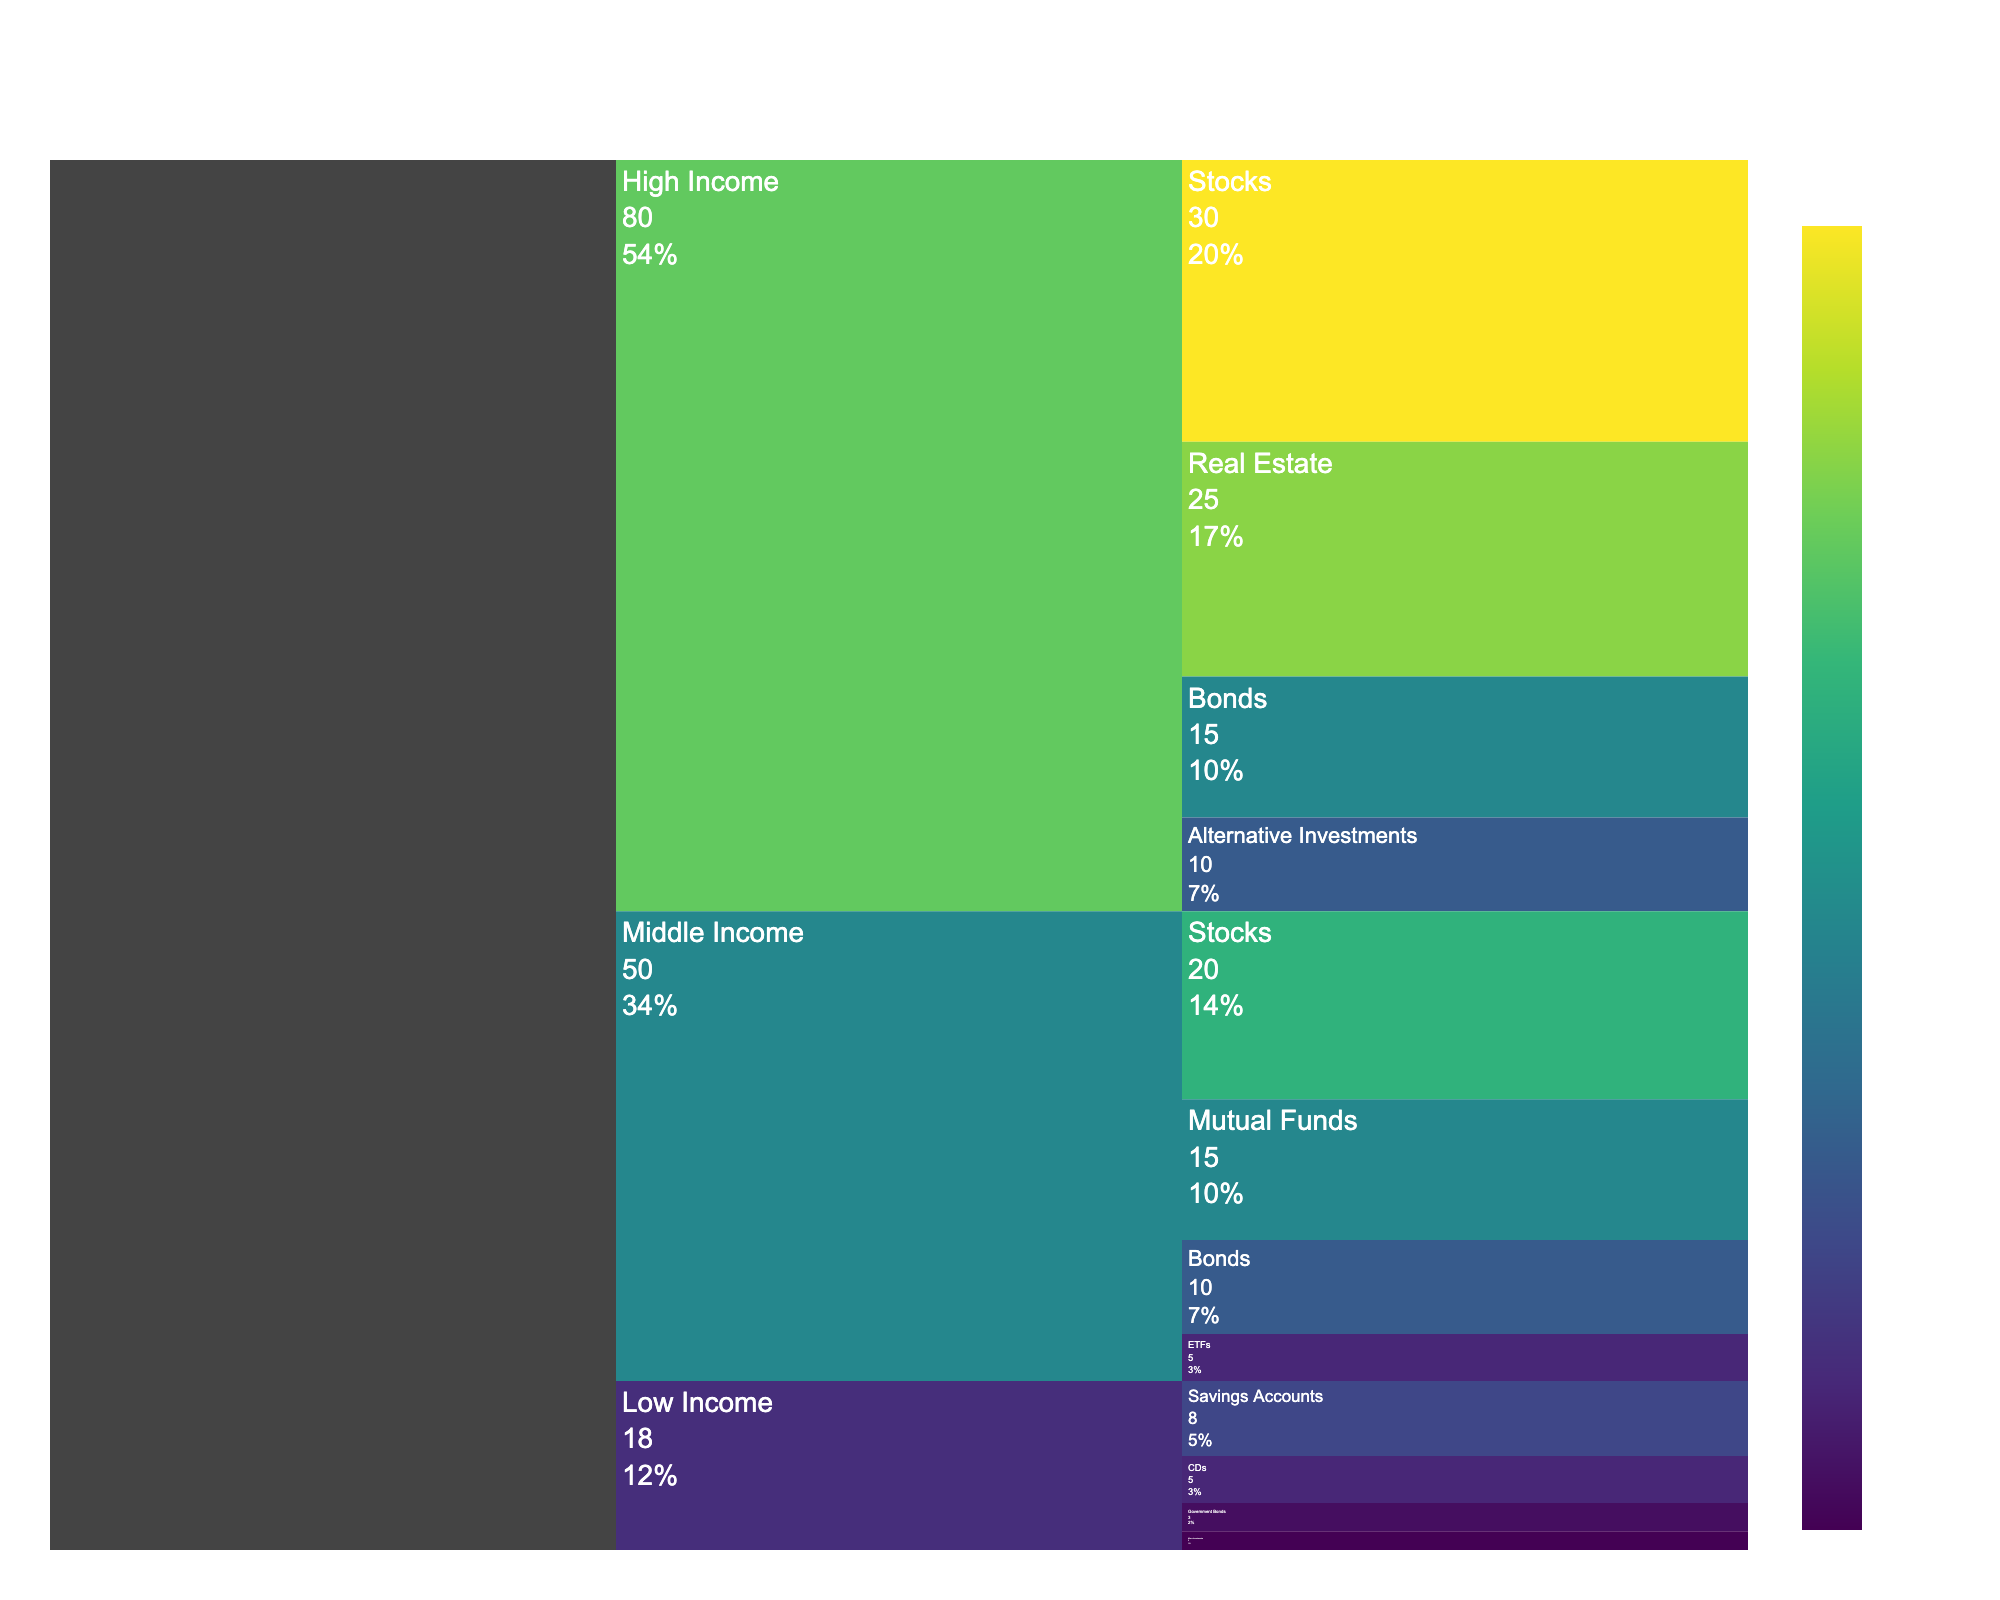What is the title of the Icicle chart? The title of the Icicle chart is positioned at the top, centered, and written in a large font.
Answer: Client Wealth Distribution by Income Bracket and Investment Type What color represents higher values on the chart? The chart uses a color scale to indicate values, where higher values are represented by colors towards the end of the Viridis color scale, typically in shades of yellow and green.
Answer: Shades of yellow and green Which investment type has the highest value for the High Income bracket? By examining the section of the Icicle chart related to the High Income bracket, you can see that the largest segment within this section is colored darker and has the highest value indicated in the hover information.
Answer: Stocks What is the total value of investments in the Middle Income bracket? To find this value, sum the indicated values of the investments (20 for Stocks, 10 for Bonds, 15 for Mutual Funds, and 5 for ETFs). So, 20 + 10 + 15 + 5 = 50.
Answer: 50 Compare the value of Stocks investments between High Income and Middle Income brackets. Which is larger? Compare the values directly from the chart; High Income has 30 and Middle Income has 20.
Answer: High Income What percentage of the total investment does the Real Estate segment represent in the High Income bracket? First, find the value for Real Estate in High Income (25). Then, find the total for High Income investments: 30 (Stocks) + 15 (Bonds) + 25 (Real Estate) + 10 (Alternative Investments) = 80. Finally, calculate the percentage (25/80) * 100 = 31.25%.
Answer: 31.25% How does the value of Government Bonds in the Low Income bracket compare to Bonds in the Middle Income bracket? Compare the values directly from the chart; Government Bonds in Low Income have a value of 3, and Bonds in Middle Income have a value of 10.
Answer: Bonds in Middle Income are larger Which bracket has the largest total value invested in Bonds? Assess the values of Bonds in each bracket and find the maximum; High Income: 15, Middle Income: 10, Low Income: not applicable.
Answer: High Income What is the total value of investments shown in the chart? Sum the values of all the investments across all brackets: High Income (30 + 15 + 25 + 10) + Middle Income (20 + 10 + 15 + 5) + Low Income (8 + 5 + 3 + 2) = 80 + 50 + 18 = 148.
Answer: 148 Which investment type in the Low Income bracket has the smallest value, and what is it? By examining the segments under Low Income, identify the smallest one which is typically the most faintly colored or labeled with the smallest value.
Answer: Micro-Investments, 2 